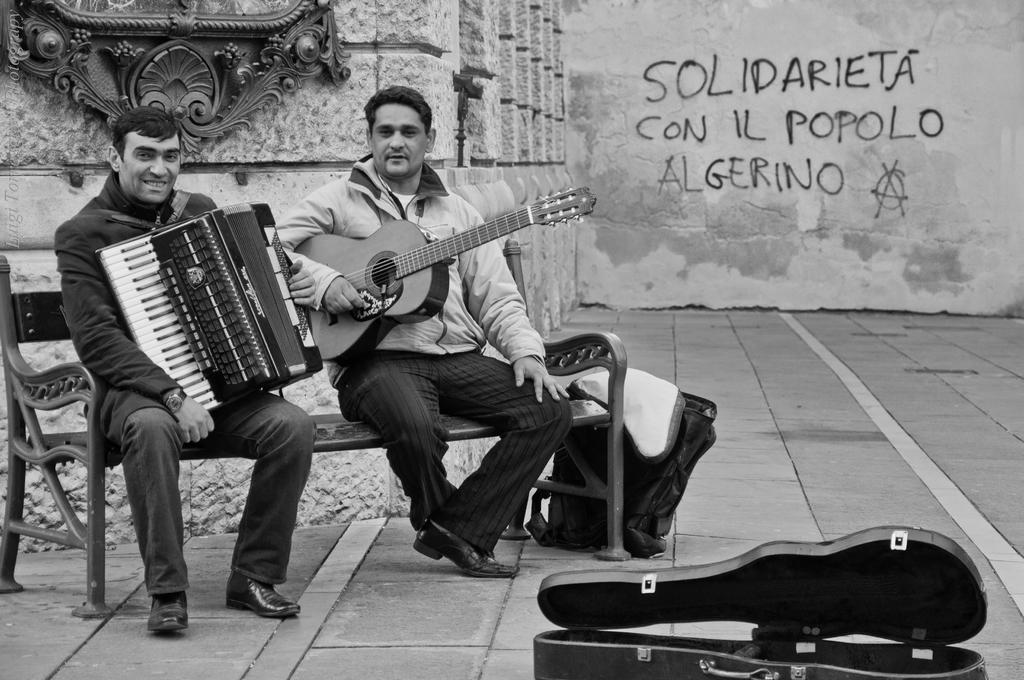Please provide a concise description of this image. In this image, we can see 2 peoples are sat on the bench. They are holding some musical instruments. The bottom we can see a musical instrument box. On the middle, there is a bag. Back Side, we can see wall, some wall hanging. 